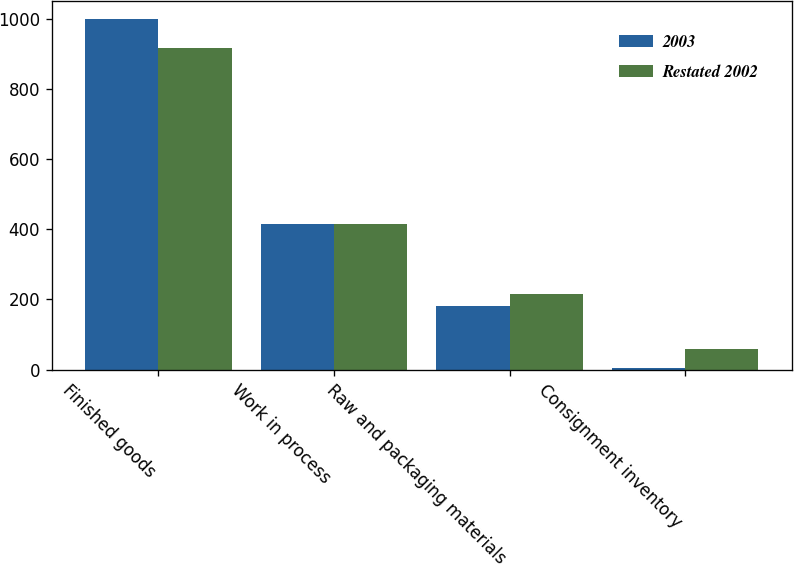Convert chart. <chart><loc_0><loc_0><loc_500><loc_500><stacked_bar_chart><ecel><fcel>Finished goods<fcel>Work in process<fcel>Raw and packaging materials<fcel>Consignment inventory<nl><fcel>2003<fcel>1001<fcel>416<fcel>180<fcel>4<nl><fcel>Restated 2002<fcel>918<fcel>416<fcel>216<fcel>58<nl></chart> 